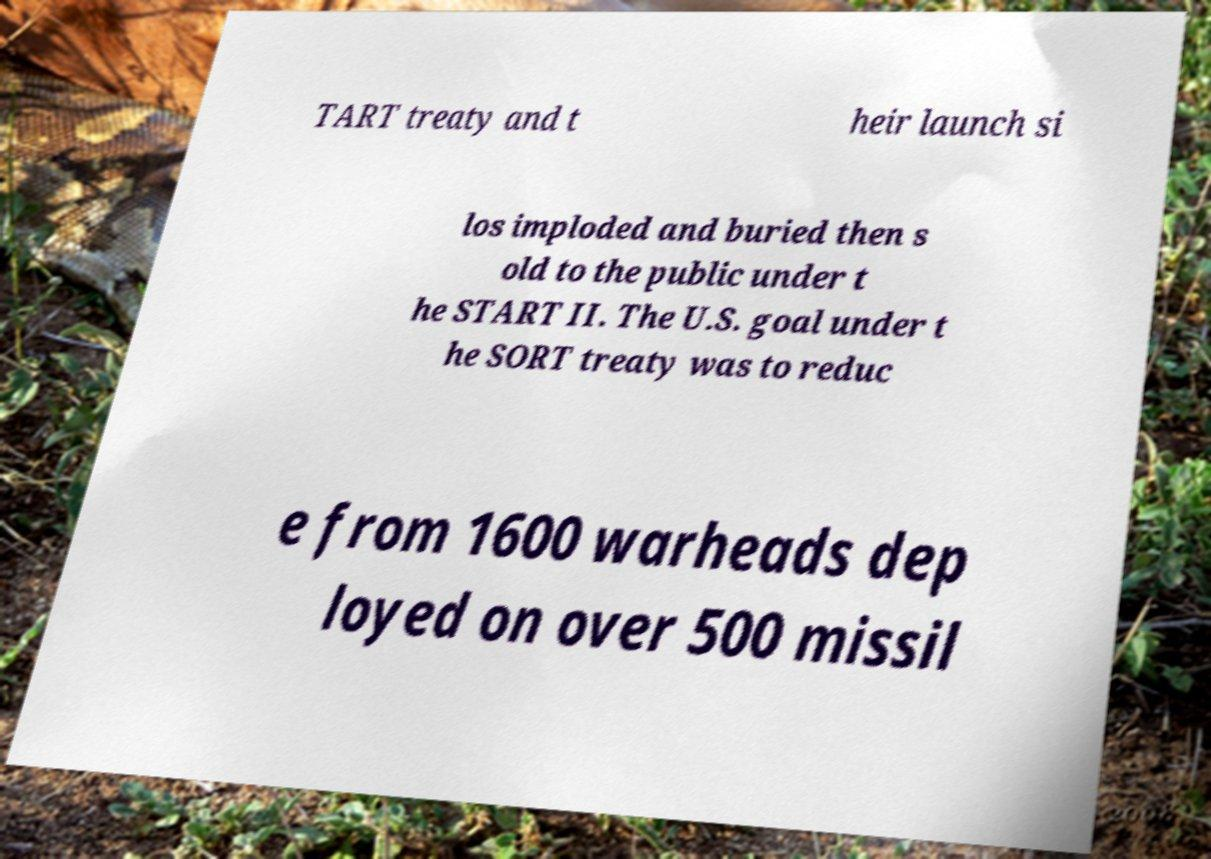What messages or text are displayed in this image? I need them in a readable, typed format. TART treaty and t heir launch si los imploded and buried then s old to the public under t he START II. The U.S. goal under t he SORT treaty was to reduc e from 1600 warheads dep loyed on over 500 missil 